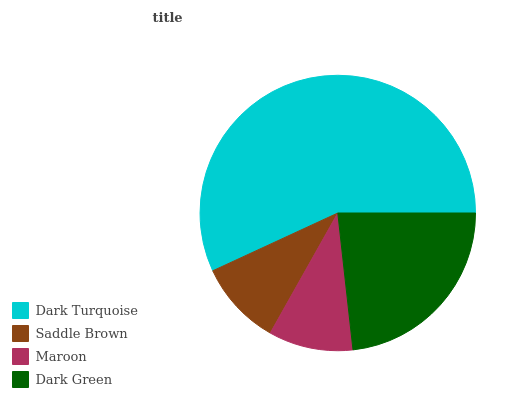Is Maroon the minimum?
Answer yes or no. Yes. Is Dark Turquoise the maximum?
Answer yes or no. Yes. Is Saddle Brown the minimum?
Answer yes or no. No. Is Saddle Brown the maximum?
Answer yes or no. No. Is Dark Turquoise greater than Saddle Brown?
Answer yes or no. Yes. Is Saddle Brown less than Dark Turquoise?
Answer yes or no. Yes. Is Saddle Brown greater than Dark Turquoise?
Answer yes or no. No. Is Dark Turquoise less than Saddle Brown?
Answer yes or no. No. Is Dark Green the high median?
Answer yes or no. Yes. Is Saddle Brown the low median?
Answer yes or no. Yes. Is Dark Turquoise the high median?
Answer yes or no. No. Is Dark Turquoise the low median?
Answer yes or no. No. 